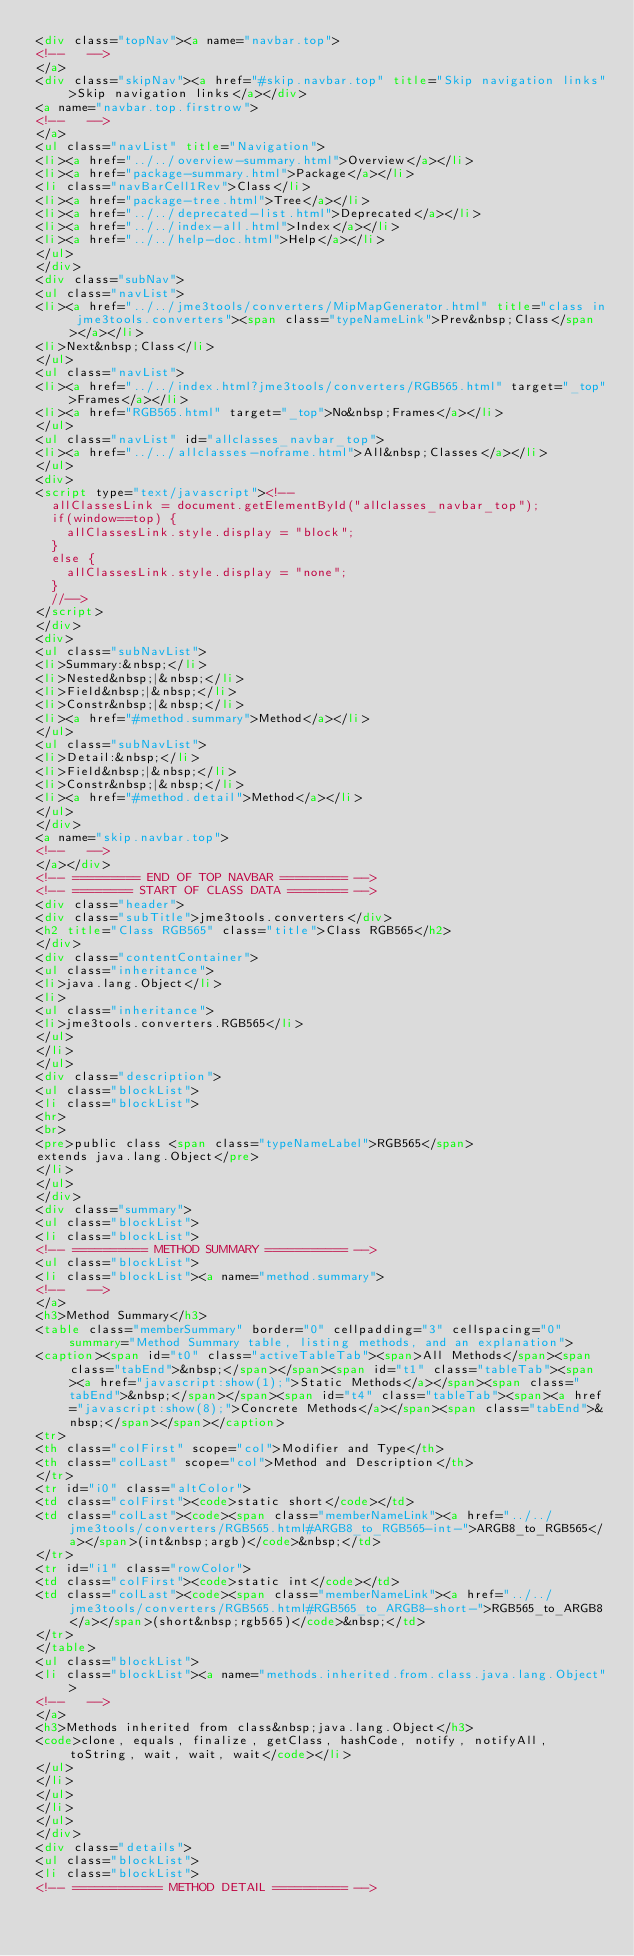Convert code to text. <code><loc_0><loc_0><loc_500><loc_500><_HTML_><div class="topNav"><a name="navbar.top">
<!--   -->
</a>
<div class="skipNav"><a href="#skip.navbar.top" title="Skip navigation links">Skip navigation links</a></div>
<a name="navbar.top.firstrow">
<!--   -->
</a>
<ul class="navList" title="Navigation">
<li><a href="../../overview-summary.html">Overview</a></li>
<li><a href="package-summary.html">Package</a></li>
<li class="navBarCell1Rev">Class</li>
<li><a href="package-tree.html">Tree</a></li>
<li><a href="../../deprecated-list.html">Deprecated</a></li>
<li><a href="../../index-all.html">Index</a></li>
<li><a href="../../help-doc.html">Help</a></li>
</ul>
</div>
<div class="subNav">
<ul class="navList">
<li><a href="../../jme3tools/converters/MipMapGenerator.html" title="class in jme3tools.converters"><span class="typeNameLink">Prev&nbsp;Class</span></a></li>
<li>Next&nbsp;Class</li>
</ul>
<ul class="navList">
<li><a href="../../index.html?jme3tools/converters/RGB565.html" target="_top">Frames</a></li>
<li><a href="RGB565.html" target="_top">No&nbsp;Frames</a></li>
</ul>
<ul class="navList" id="allclasses_navbar_top">
<li><a href="../../allclasses-noframe.html">All&nbsp;Classes</a></li>
</ul>
<div>
<script type="text/javascript"><!--
  allClassesLink = document.getElementById("allclasses_navbar_top");
  if(window==top) {
    allClassesLink.style.display = "block";
  }
  else {
    allClassesLink.style.display = "none";
  }
  //-->
</script>
</div>
<div>
<ul class="subNavList">
<li>Summary:&nbsp;</li>
<li>Nested&nbsp;|&nbsp;</li>
<li>Field&nbsp;|&nbsp;</li>
<li>Constr&nbsp;|&nbsp;</li>
<li><a href="#method.summary">Method</a></li>
</ul>
<ul class="subNavList">
<li>Detail:&nbsp;</li>
<li>Field&nbsp;|&nbsp;</li>
<li>Constr&nbsp;|&nbsp;</li>
<li><a href="#method.detail">Method</a></li>
</ul>
</div>
<a name="skip.navbar.top">
<!--   -->
</a></div>
<!-- ========= END OF TOP NAVBAR ========= -->
<!-- ======== START OF CLASS DATA ======== -->
<div class="header">
<div class="subTitle">jme3tools.converters</div>
<h2 title="Class RGB565" class="title">Class RGB565</h2>
</div>
<div class="contentContainer">
<ul class="inheritance">
<li>java.lang.Object</li>
<li>
<ul class="inheritance">
<li>jme3tools.converters.RGB565</li>
</ul>
</li>
</ul>
<div class="description">
<ul class="blockList">
<li class="blockList">
<hr>
<br>
<pre>public class <span class="typeNameLabel">RGB565</span>
extends java.lang.Object</pre>
</li>
</ul>
</div>
<div class="summary">
<ul class="blockList">
<li class="blockList">
<!-- ========== METHOD SUMMARY =========== -->
<ul class="blockList">
<li class="blockList"><a name="method.summary">
<!--   -->
</a>
<h3>Method Summary</h3>
<table class="memberSummary" border="0" cellpadding="3" cellspacing="0" summary="Method Summary table, listing methods, and an explanation">
<caption><span id="t0" class="activeTableTab"><span>All Methods</span><span class="tabEnd">&nbsp;</span></span><span id="t1" class="tableTab"><span><a href="javascript:show(1);">Static Methods</a></span><span class="tabEnd">&nbsp;</span></span><span id="t4" class="tableTab"><span><a href="javascript:show(8);">Concrete Methods</a></span><span class="tabEnd">&nbsp;</span></span></caption>
<tr>
<th class="colFirst" scope="col">Modifier and Type</th>
<th class="colLast" scope="col">Method and Description</th>
</tr>
<tr id="i0" class="altColor">
<td class="colFirst"><code>static short</code></td>
<td class="colLast"><code><span class="memberNameLink"><a href="../../jme3tools/converters/RGB565.html#ARGB8_to_RGB565-int-">ARGB8_to_RGB565</a></span>(int&nbsp;argb)</code>&nbsp;</td>
</tr>
<tr id="i1" class="rowColor">
<td class="colFirst"><code>static int</code></td>
<td class="colLast"><code><span class="memberNameLink"><a href="../../jme3tools/converters/RGB565.html#RGB565_to_ARGB8-short-">RGB565_to_ARGB8</a></span>(short&nbsp;rgb565)</code>&nbsp;</td>
</tr>
</table>
<ul class="blockList">
<li class="blockList"><a name="methods.inherited.from.class.java.lang.Object">
<!--   -->
</a>
<h3>Methods inherited from class&nbsp;java.lang.Object</h3>
<code>clone, equals, finalize, getClass, hashCode, notify, notifyAll, toString, wait, wait, wait</code></li>
</ul>
</li>
</ul>
</li>
</ul>
</div>
<div class="details">
<ul class="blockList">
<li class="blockList">
<!-- ============ METHOD DETAIL ========== --></code> 